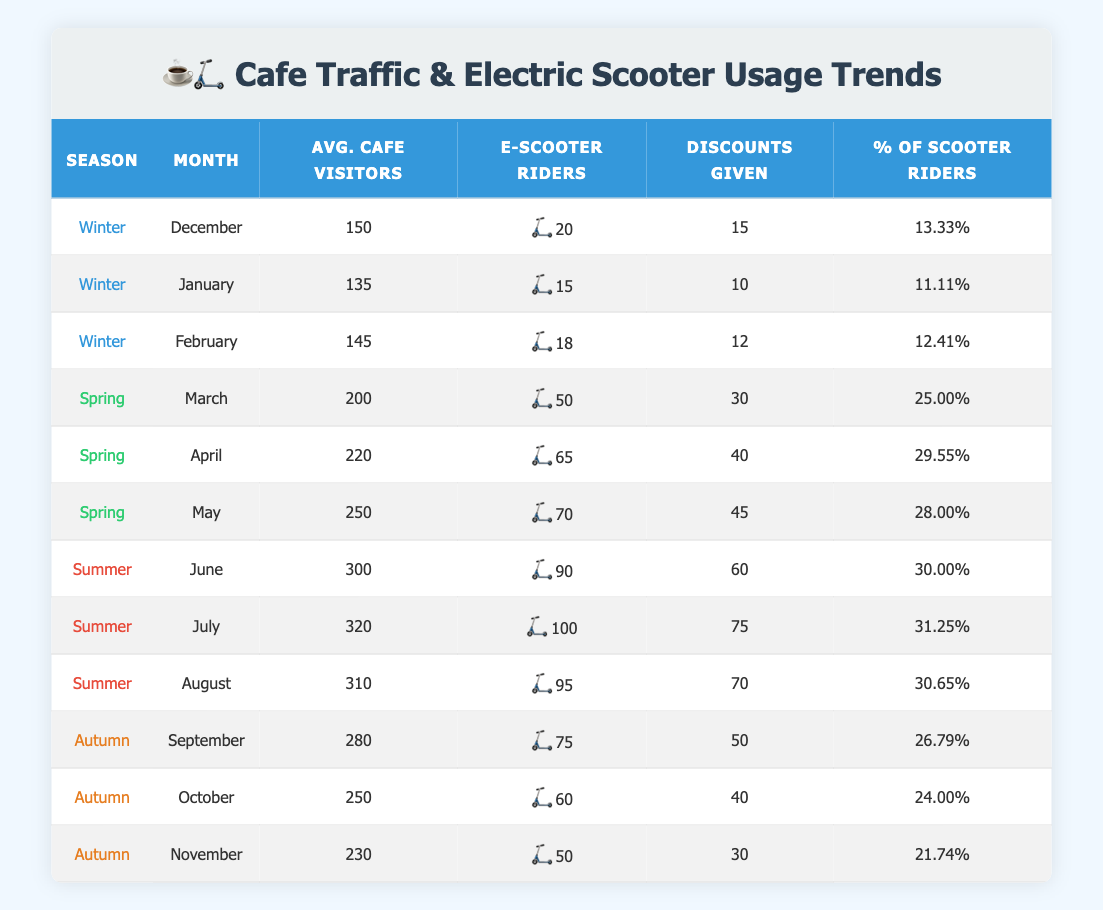What is the average number of electric scooter riders in Spring? To find the average number of electric scooter riders in Spring, I will add the numbers of scooter riders in March (50), April (65), and May (70), giving a total of 50 + 65 + 70 = 185. There are three months, so the average is 185 / 3 ≈ 61.67.
Answer: 61.67 During which month in Summer did the cafe have the highest percentage of electric scooter riders? I will check the percentage of electric scooter riders for June (30%), July (31.25%), and August (30.65%). The highest percentage is in July with 31.25%.
Answer: July How many total discounts were given in Winter? The total discounts given in Winter are found by adding the discounts given in December (15), January (10), and February (12): 15 + 10 + 12 = 37.
Answer: 37 Is it true that in Autumn, there were more electric scooter riders in September than in November? The number of electric scooter riders in September is 75, while in November it is 50. Since 75 is greater than 50, the statement is true.
Answer: Yes What is the percentage of electric scooter riders in February? The table shows that the percentage of electric scooter riders in February is listed as 12.41%.
Answer: 12.41% Which season had the highest average number of cafe visitors? I will calculate the average for each season: Winter (average of 150, 135, 145 = 143.33), Spring (average of 200, 220, 250 = 223.33), Summer (average of 300, 320, 310 = 310), and Autumn (average of 280, 250, 230 = 253.33). Summer has the highest average at 310.
Answer: Summer What is the total average number of cafe visitors across all seasons? To find the total average, I will sum the average visitors from each month: (150 + 135 + 145 + 200 + 220 + 250 + 300 + 320 + 310 + 280 + 250 + 230) = 2,720. There are 12 months; therefore, the average is 2,720 / 12 ≈ 226.67.
Answer: 226.67 Which month had fewer average cafe visitors: January or November? The average cafe visitors in January are 135, and in November, they are 230. Since 135 is less than 230, January had fewer visitors.
Answer: January 